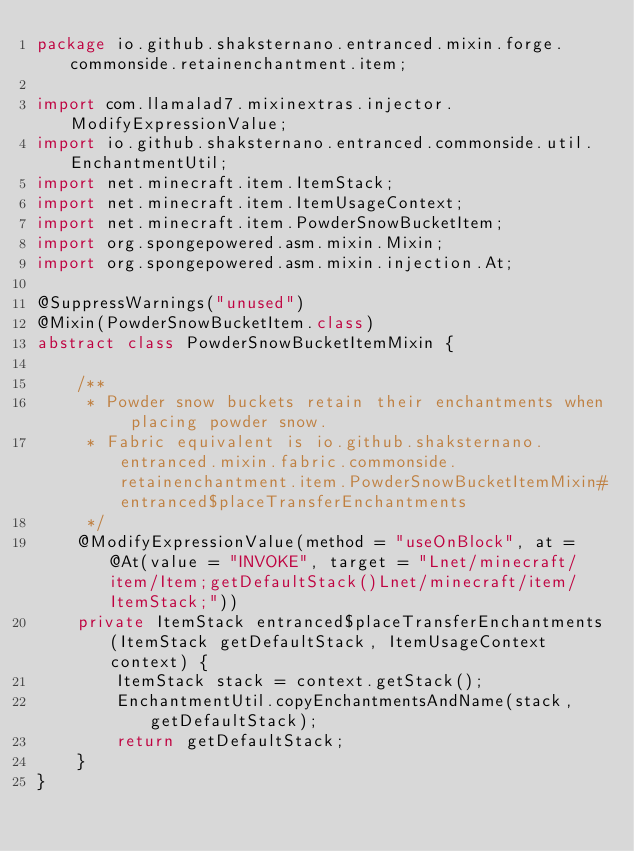Convert code to text. <code><loc_0><loc_0><loc_500><loc_500><_Java_>package io.github.shaksternano.entranced.mixin.forge.commonside.retainenchantment.item;

import com.llamalad7.mixinextras.injector.ModifyExpressionValue;
import io.github.shaksternano.entranced.commonside.util.EnchantmentUtil;
import net.minecraft.item.ItemStack;
import net.minecraft.item.ItemUsageContext;
import net.minecraft.item.PowderSnowBucketItem;
import org.spongepowered.asm.mixin.Mixin;
import org.spongepowered.asm.mixin.injection.At;

@SuppressWarnings("unused")
@Mixin(PowderSnowBucketItem.class)
abstract class PowderSnowBucketItemMixin {

    /**
     * Powder snow buckets retain their enchantments when placing powder snow.
     * Fabric equivalent is io.github.shaksternano.entranced.mixin.fabric.commonside.retainenchantment.item.PowderSnowBucketItemMixin#entranced$placeTransferEnchantments
     */
    @ModifyExpressionValue(method = "useOnBlock", at = @At(value = "INVOKE", target = "Lnet/minecraft/item/Item;getDefaultStack()Lnet/minecraft/item/ItemStack;"))
    private ItemStack entranced$placeTransferEnchantments(ItemStack getDefaultStack, ItemUsageContext context) {
        ItemStack stack = context.getStack();
        EnchantmentUtil.copyEnchantmentsAndName(stack, getDefaultStack);
        return getDefaultStack;
    }
}
</code> 